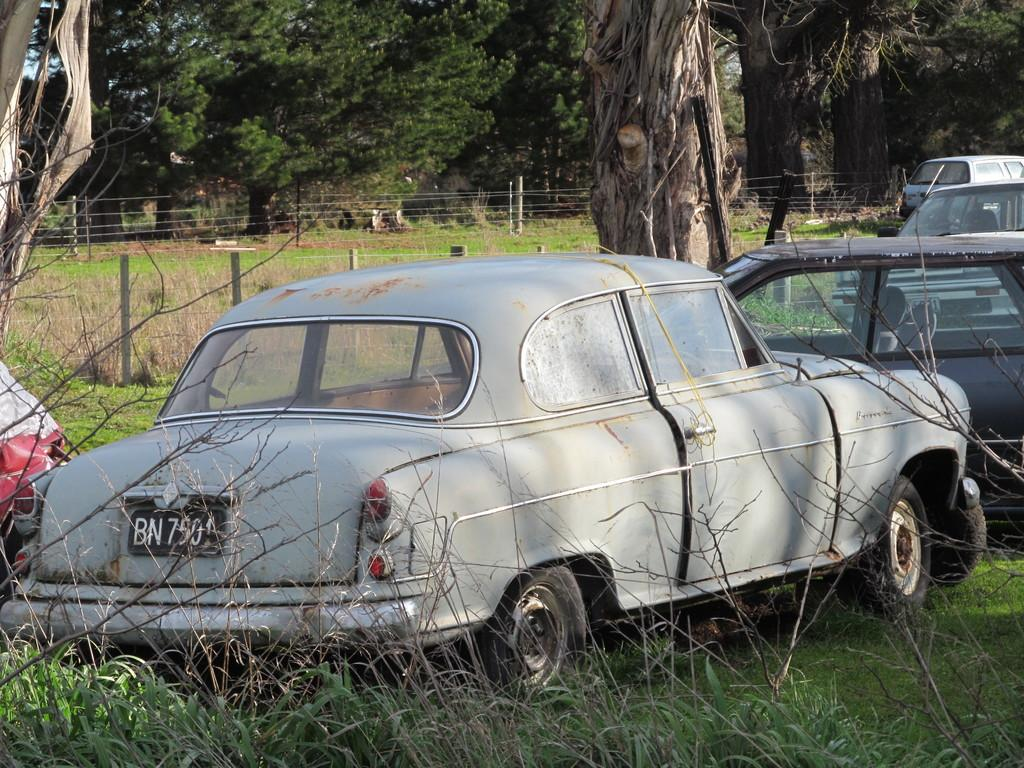What types of objects are present in the image? There are vehicles in the image. What type of natural environment can be seen in the image? There is grass in the image. What type of barrier is visible in the image? There is a fence in the image. What can be seen in the background of the image? There are trees in the background of the image. How much money is being exchanged between the vehicles in the image? There is no indication of money being exchanged in the image; it features vehicles, grass, a fence, and trees. Can you describe the kitty playing with the vehicles in the image? There is no kitty present in the image; it only features vehicles, grass, a fence, and trees. 